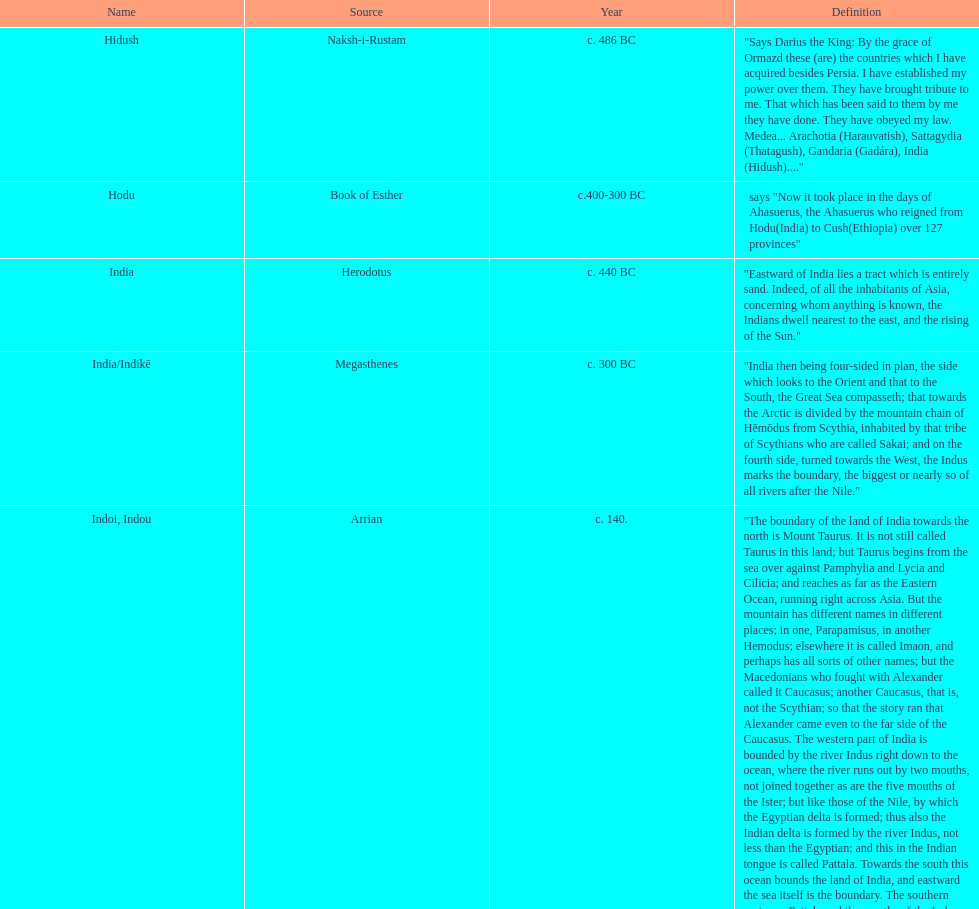What was the nation called before the book of esther called it hodu? Hidush. 